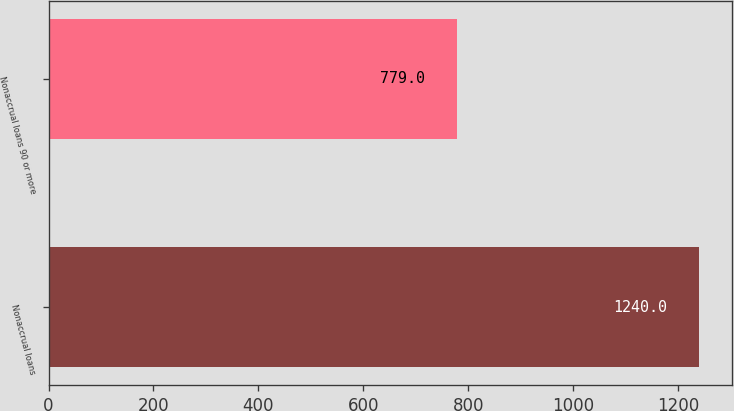<chart> <loc_0><loc_0><loc_500><loc_500><bar_chart><fcel>Nonaccrual loans<fcel>Nonaccrual loans 90 or more<nl><fcel>1240<fcel>779<nl></chart> 